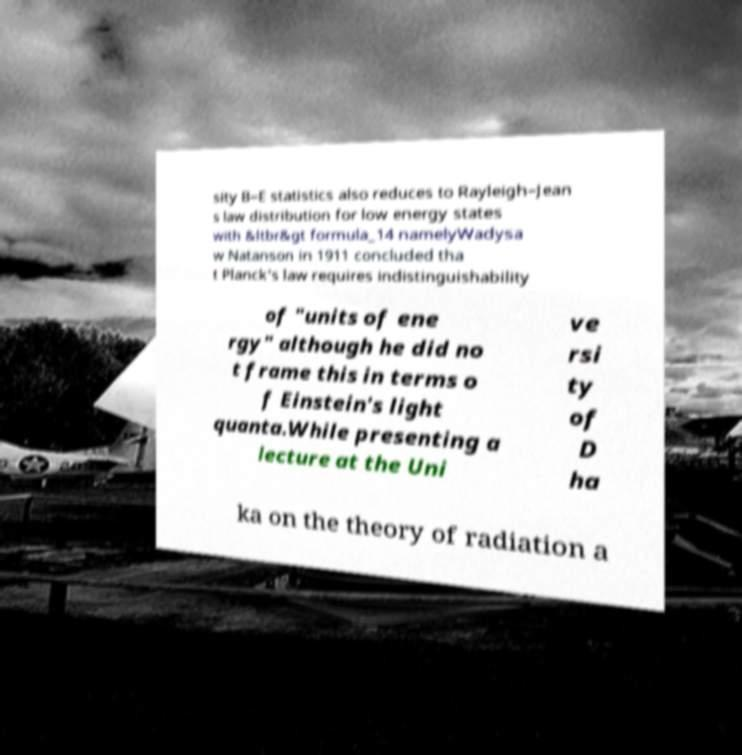Could you extract and type out the text from this image? sity B–E statistics also reduces to Rayleigh–Jean s law distribution for low energy states with &ltbr&gt formula_14 namelyWadysa w Natanson in 1911 concluded tha t Planck's law requires indistinguishability of "units of ene rgy" although he did no t frame this in terms o f Einstein's light quanta.While presenting a lecture at the Uni ve rsi ty of D ha ka on the theory of radiation a 